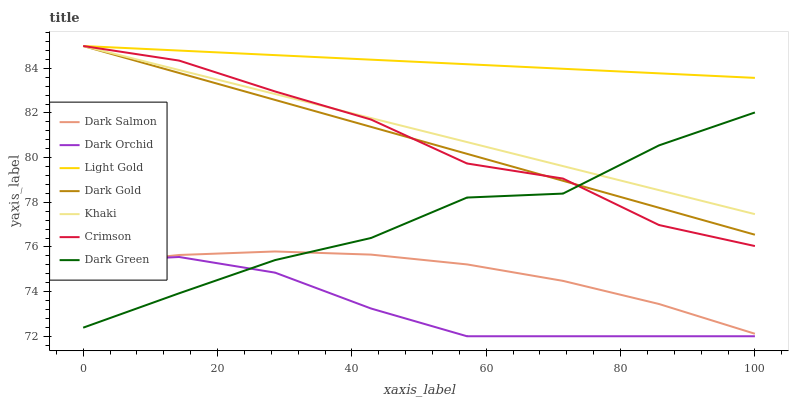Does Dark Orchid have the minimum area under the curve?
Answer yes or no. Yes. Does Light Gold have the maximum area under the curve?
Answer yes or no. Yes. Does Dark Gold have the minimum area under the curve?
Answer yes or no. No. Does Dark Gold have the maximum area under the curve?
Answer yes or no. No. Is Light Gold the smoothest?
Answer yes or no. Yes. Is Dark Green the roughest?
Answer yes or no. Yes. Is Dark Gold the smoothest?
Answer yes or no. No. Is Dark Gold the roughest?
Answer yes or no. No. Does Dark Orchid have the lowest value?
Answer yes or no. Yes. Does Dark Gold have the lowest value?
Answer yes or no. No. Does Light Gold have the highest value?
Answer yes or no. Yes. Does Dark Salmon have the highest value?
Answer yes or no. No. Is Dark Salmon less than Light Gold?
Answer yes or no. Yes. Is Dark Gold greater than Dark Salmon?
Answer yes or no. Yes. Does Dark Orchid intersect Dark Salmon?
Answer yes or no. Yes. Is Dark Orchid less than Dark Salmon?
Answer yes or no. No. Is Dark Orchid greater than Dark Salmon?
Answer yes or no. No. Does Dark Salmon intersect Light Gold?
Answer yes or no. No. 